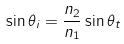<formula> <loc_0><loc_0><loc_500><loc_500>\sin \theta _ { i } = \frac { n _ { 2 } } { n _ { 1 } } \sin \theta _ { t }</formula> 